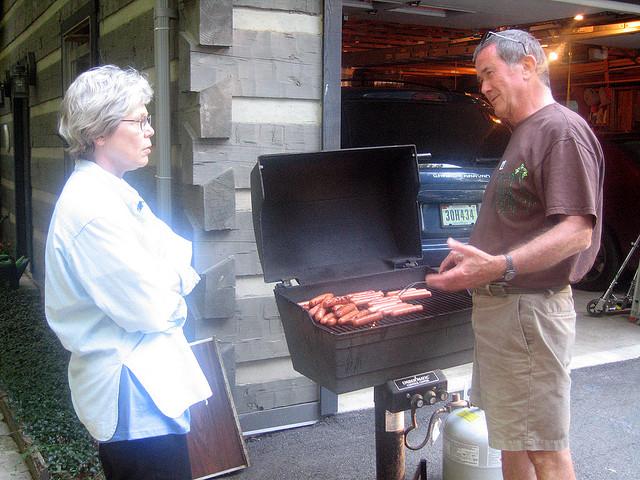Is this being done in the back of the house?
Give a very brief answer. No. Is he making tacos?
Quick response, please. No. What is the man cooking?
Write a very short answer. Hot dogs. 